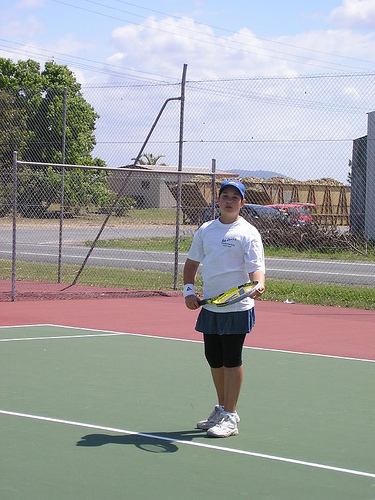<image>What is the graphic on the man's shirt? I am not sure. The graphic on the man's shirt can be a logo, text, or a company name such as Adidas or Nike. What is the girl looking at? I cannot definitively determine what the girl is looking at. It could be the camera or a ball. What is the graphic on the man's shirt? I am not sure what is the graphic on the man's shirt. It can be seen 'logo', 'adidas', 'f', 'text', 'none', 'blurry', 'company name' or 'nike'. What is the girl looking at? I am not certain what the girl is looking at. It could be the camera or a ball. 